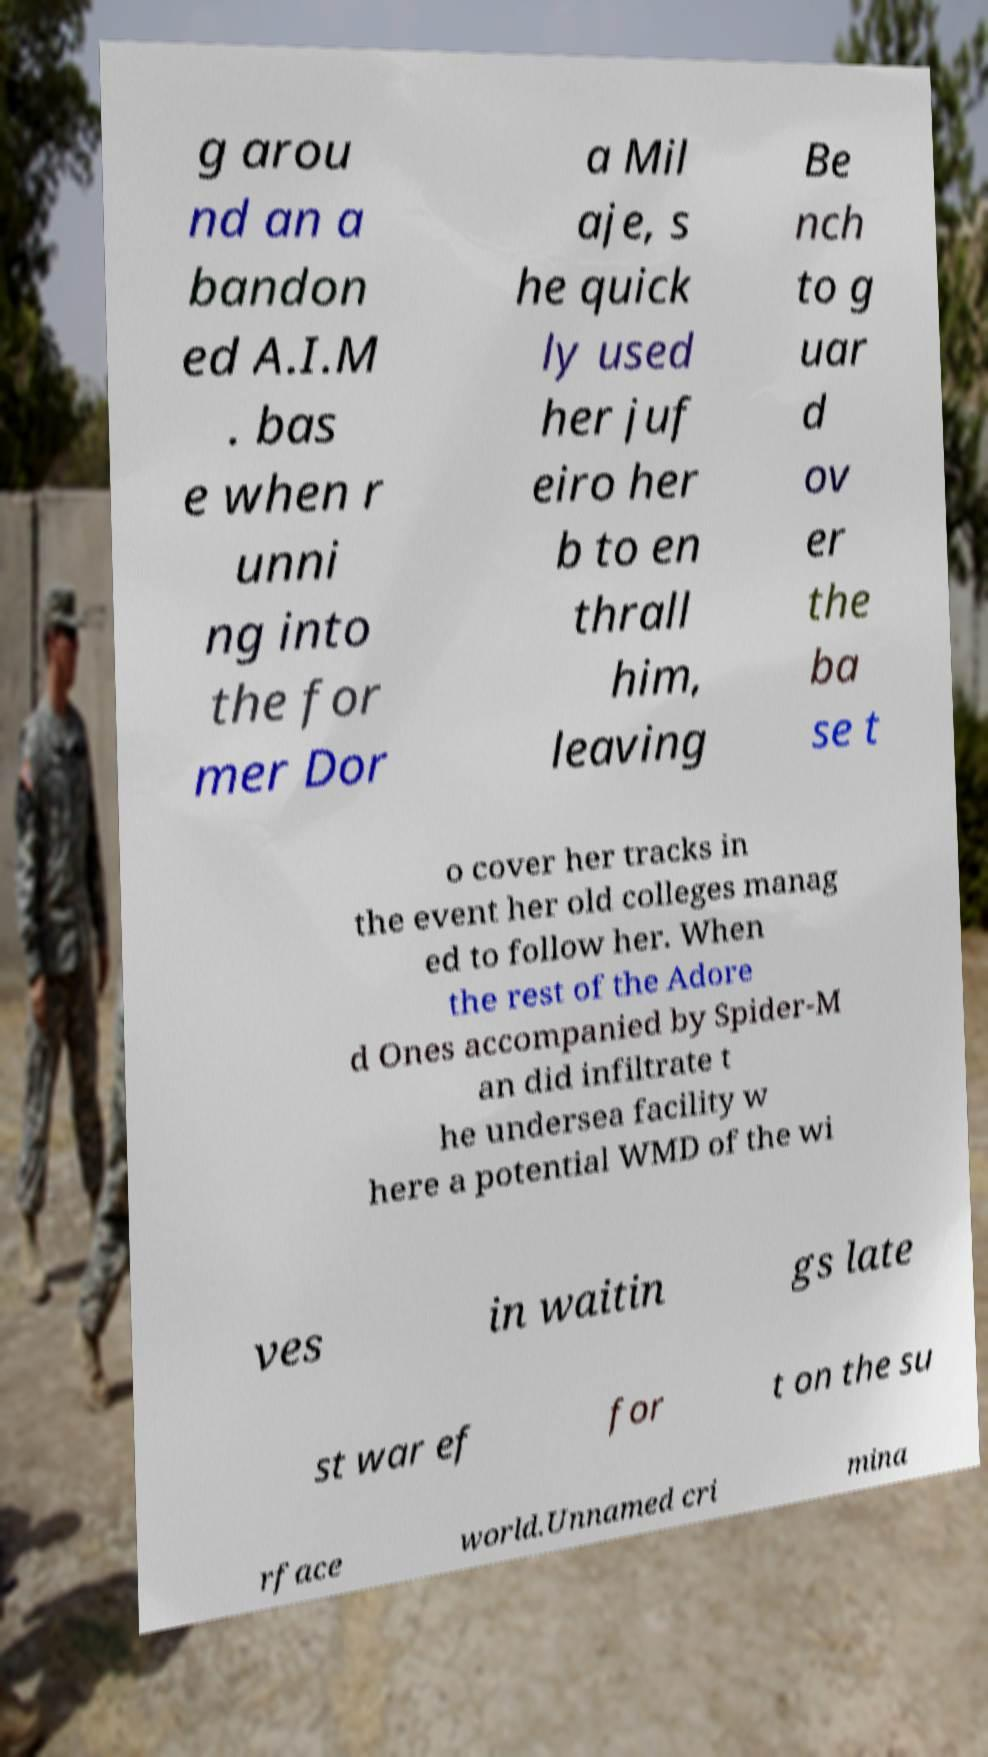I need the written content from this picture converted into text. Can you do that? g arou nd an a bandon ed A.I.M . bas e when r unni ng into the for mer Dor a Mil aje, s he quick ly used her juf eiro her b to en thrall him, leaving Be nch to g uar d ov er the ba se t o cover her tracks in the event her old colleges manag ed to follow her. When the rest of the Adore d Ones accompanied by Spider-M an did infiltrate t he undersea facility w here a potential WMD of the wi ves in waitin gs late st war ef for t on the su rface world.Unnamed cri mina 